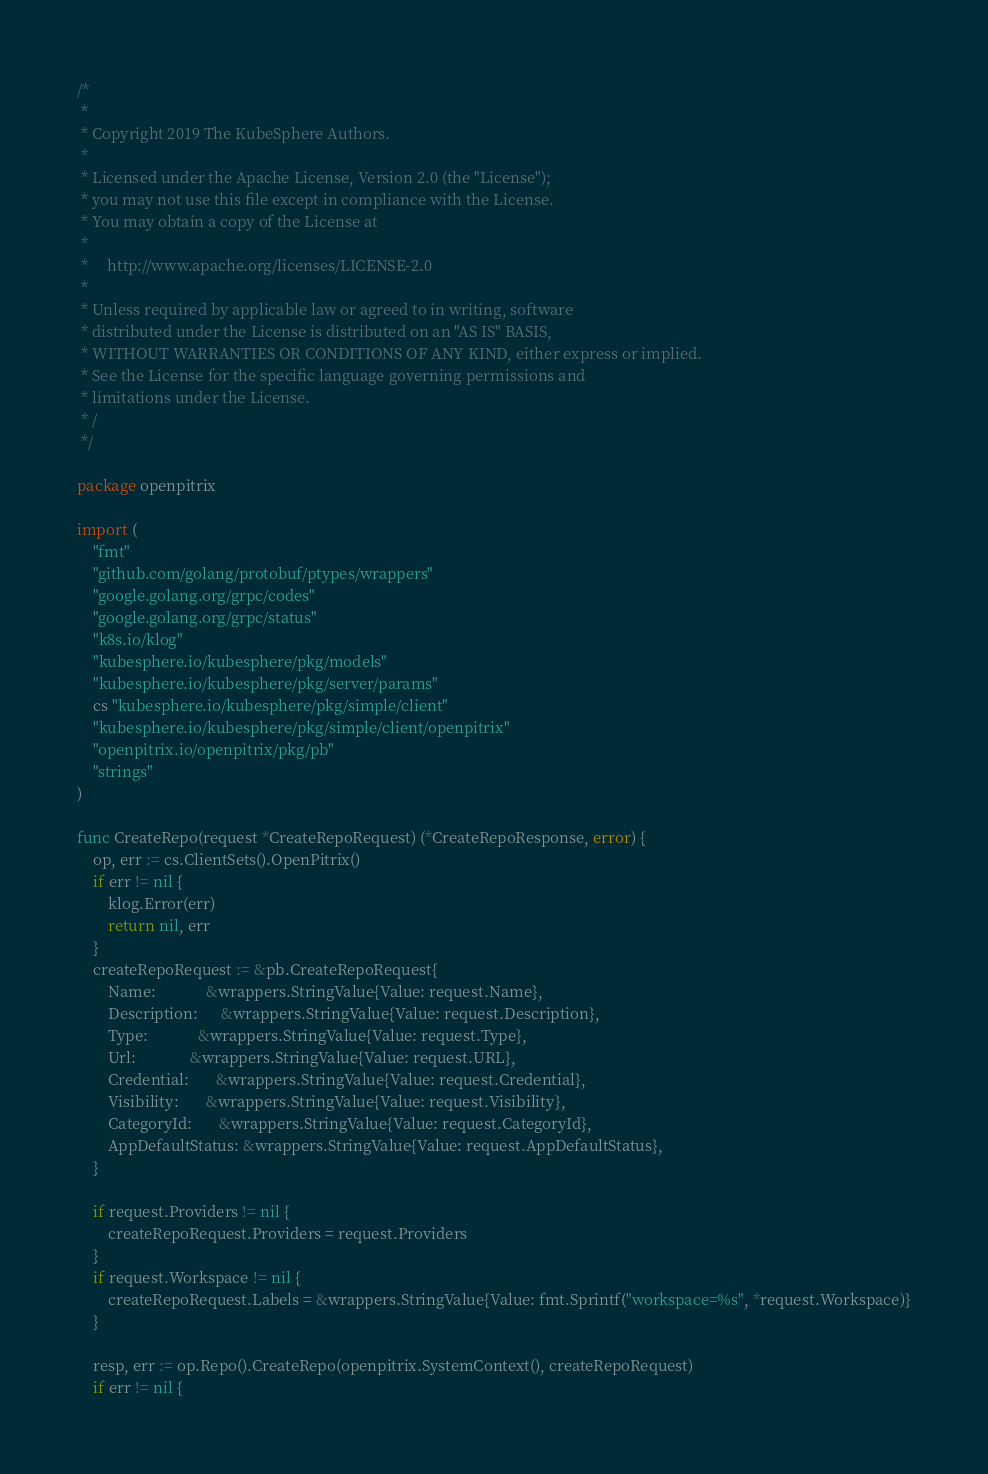<code> <loc_0><loc_0><loc_500><loc_500><_Go_>/*
 *
 * Copyright 2019 The KubeSphere Authors.
 *
 * Licensed under the Apache License, Version 2.0 (the "License");
 * you may not use this file except in compliance with the License.
 * You may obtain a copy of the License at
 *
 *     http://www.apache.org/licenses/LICENSE-2.0
 *
 * Unless required by applicable law or agreed to in writing, software
 * distributed under the License is distributed on an "AS IS" BASIS,
 * WITHOUT WARRANTIES OR CONDITIONS OF ANY KIND, either express or implied.
 * See the License for the specific language governing permissions and
 * limitations under the License.
 * /
 */

package openpitrix

import (
	"fmt"
	"github.com/golang/protobuf/ptypes/wrappers"
	"google.golang.org/grpc/codes"
	"google.golang.org/grpc/status"
	"k8s.io/klog"
	"kubesphere.io/kubesphere/pkg/models"
	"kubesphere.io/kubesphere/pkg/server/params"
	cs "kubesphere.io/kubesphere/pkg/simple/client"
	"kubesphere.io/kubesphere/pkg/simple/client/openpitrix"
	"openpitrix.io/openpitrix/pkg/pb"
	"strings"
)

func CreateRepo(request *CreateRepoRequest) (*CreateRepoResponse, error) {
	op, err := cs.ClientSets().OpenPitrix()
	if err != nil {
		klog.Error(err)
		return nil, err
	}
	createRepoRequest := &pb.CreateRepoRequest{
		Name:             &wrappers.StringValue{Value: request.Name},
		Description:      &wrappers.StringValue{Value: request.Description},
		Type:             &wrappers.StringValue{Value: request.Type},
		Url:              &wrappers.StringValue{Value: request.URL},
		Credential:       &wrappers.StringValue{Value: request.Credential},
		Visibility:       &wrappers.StringValue{Value: request.Visibility},
		CategoryId:       &wrappers.StringValue{Value: request.CategoryId},
		AppDefaultStatus: &wrappers.StringValue{Value: request.AppDefaultStatus},
	}

	if request.Providers != nil {
		createRepoRequest.Providers = request.Providers
	}
	if request.Workspace != nil {
		createRepoRequest.Labels = &wrappers.StringValue{Value: fmt.Sprintf("workspace=%s", *request.Workspace)}
	}

	resp, err := op.Repo().CreateRepo(openpitrix.SystemContext(), createRepoRequest)
	if err != nil {</code> 